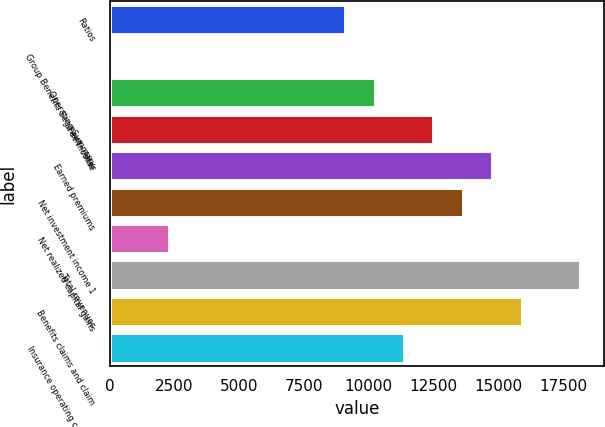Convert chart. <chart><loc_0><loc_0><loc_500><loc_500><bar_chart><fcel>Ratios<fcel>Group Benefits Segment - After<fcel>Operating Summary<fcel>Fee income<fcel>Earned premiums<fcel>Net investment income 1<fcel>Net realized capital gains<fcel>Total revenues<fcel>Benefits claims and claim<fcel>Insurance operating costs and<nl><fcel>9089.26<fcel>6.3<fcel>10224.6<fcel>12495.4<fcel>14766.1<fcel>13630.7<fcel>2277.04<fcel>18172.2<fcel>15901.5<fcel>11360<nl></chart> 